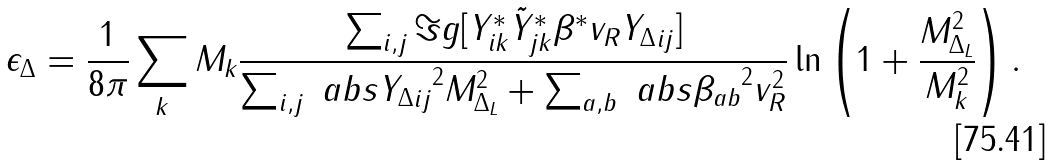<formula> <loc_0><loc_0><loc_500><loc_500>\epsilon _ { \Delta } = \frac { 1 } { 8 \pi } \sum _ { k } M _ { k } \frac { \sum _ { i , j } \Im g [ Y ^ { \ast } _ { i k } \tilde { Y } ^ { \ast } _ { j k } \beta ^ { \ast } v _ { R } { Y _ { \Delta } } _ { i j } ] } { \sum _ { i , j } \ a b s { { Y _ { \Delta } } _ { i j } } ^ { 2 } M _ { \Delta _ { L } } ^ { 2 } + \sum _ { a , b } \ a b s { \beta _ { a b } } ^ { 2 } v _ { R } ^ { 2 } } \ln \left ( 1 + \frac { M _ { \Delta _ { L } } ^ { 2 } } { M _ { k } ^ { 2 } } \right ) .</formula> 